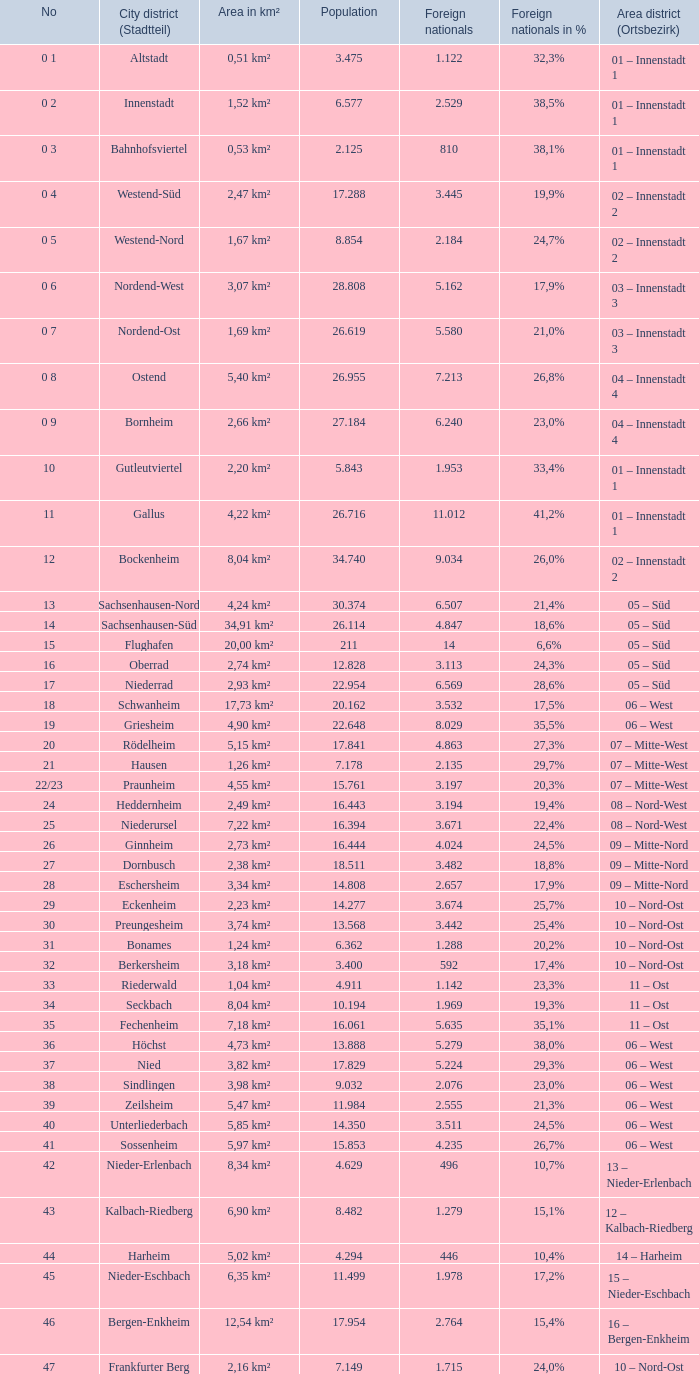How many foreigners in percentage terms had a population of 4.911? 1.0. 